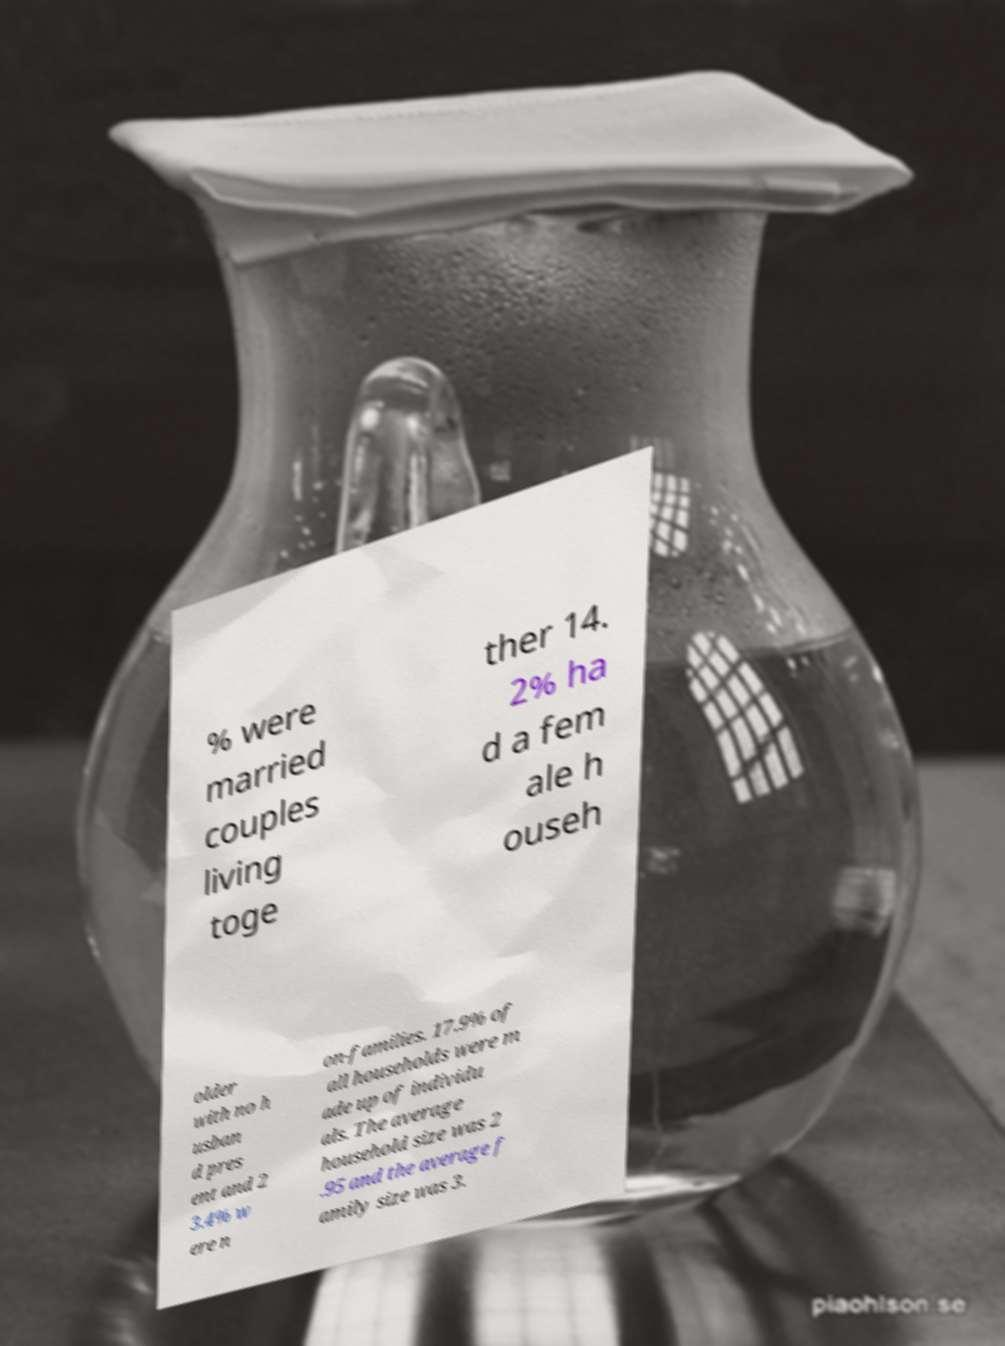Could you assist in decoding the text presented in this image and type it out clearly? % were married couples living toge ther 14. 2% ha d a fem ale h ouseh older with no h usban d pres ent and 2 3.4% w ere n on-families. 17.9% of all households were m ade up of individu als. The average household size was 2 .95 and the average f amily size was 3. 